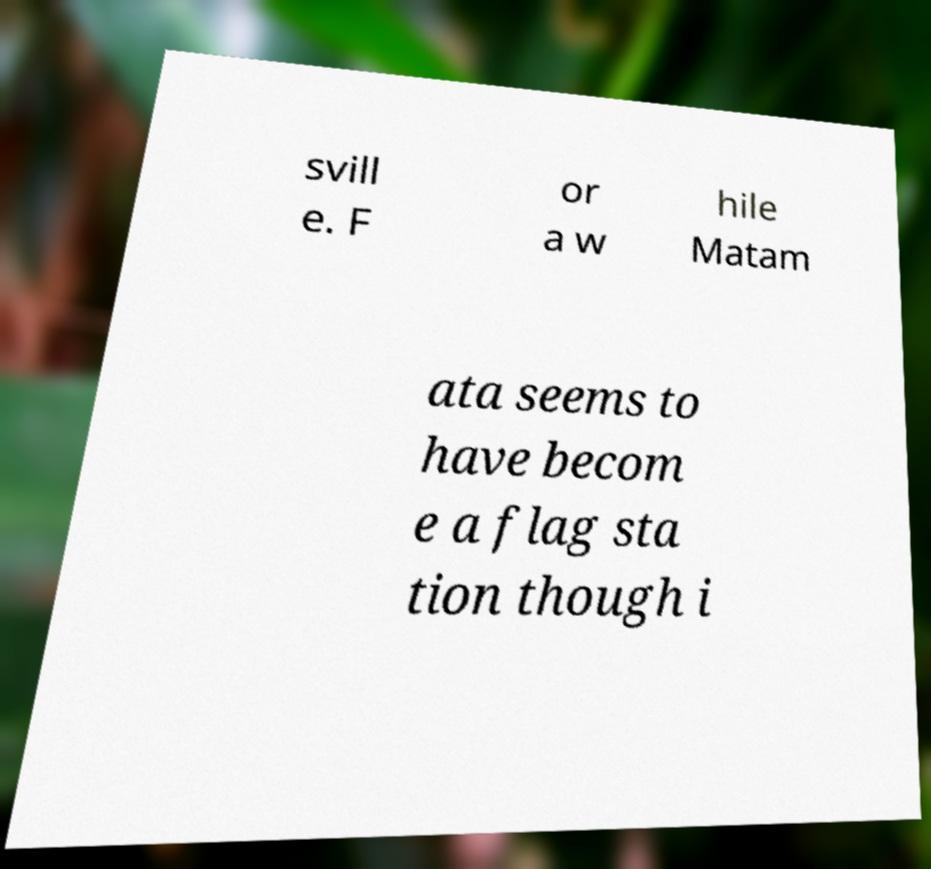Please read and relay the text visible in this image. What does it say? svill e. F or a w hile Matam ata seems to have becom e a flag sta tion though i 